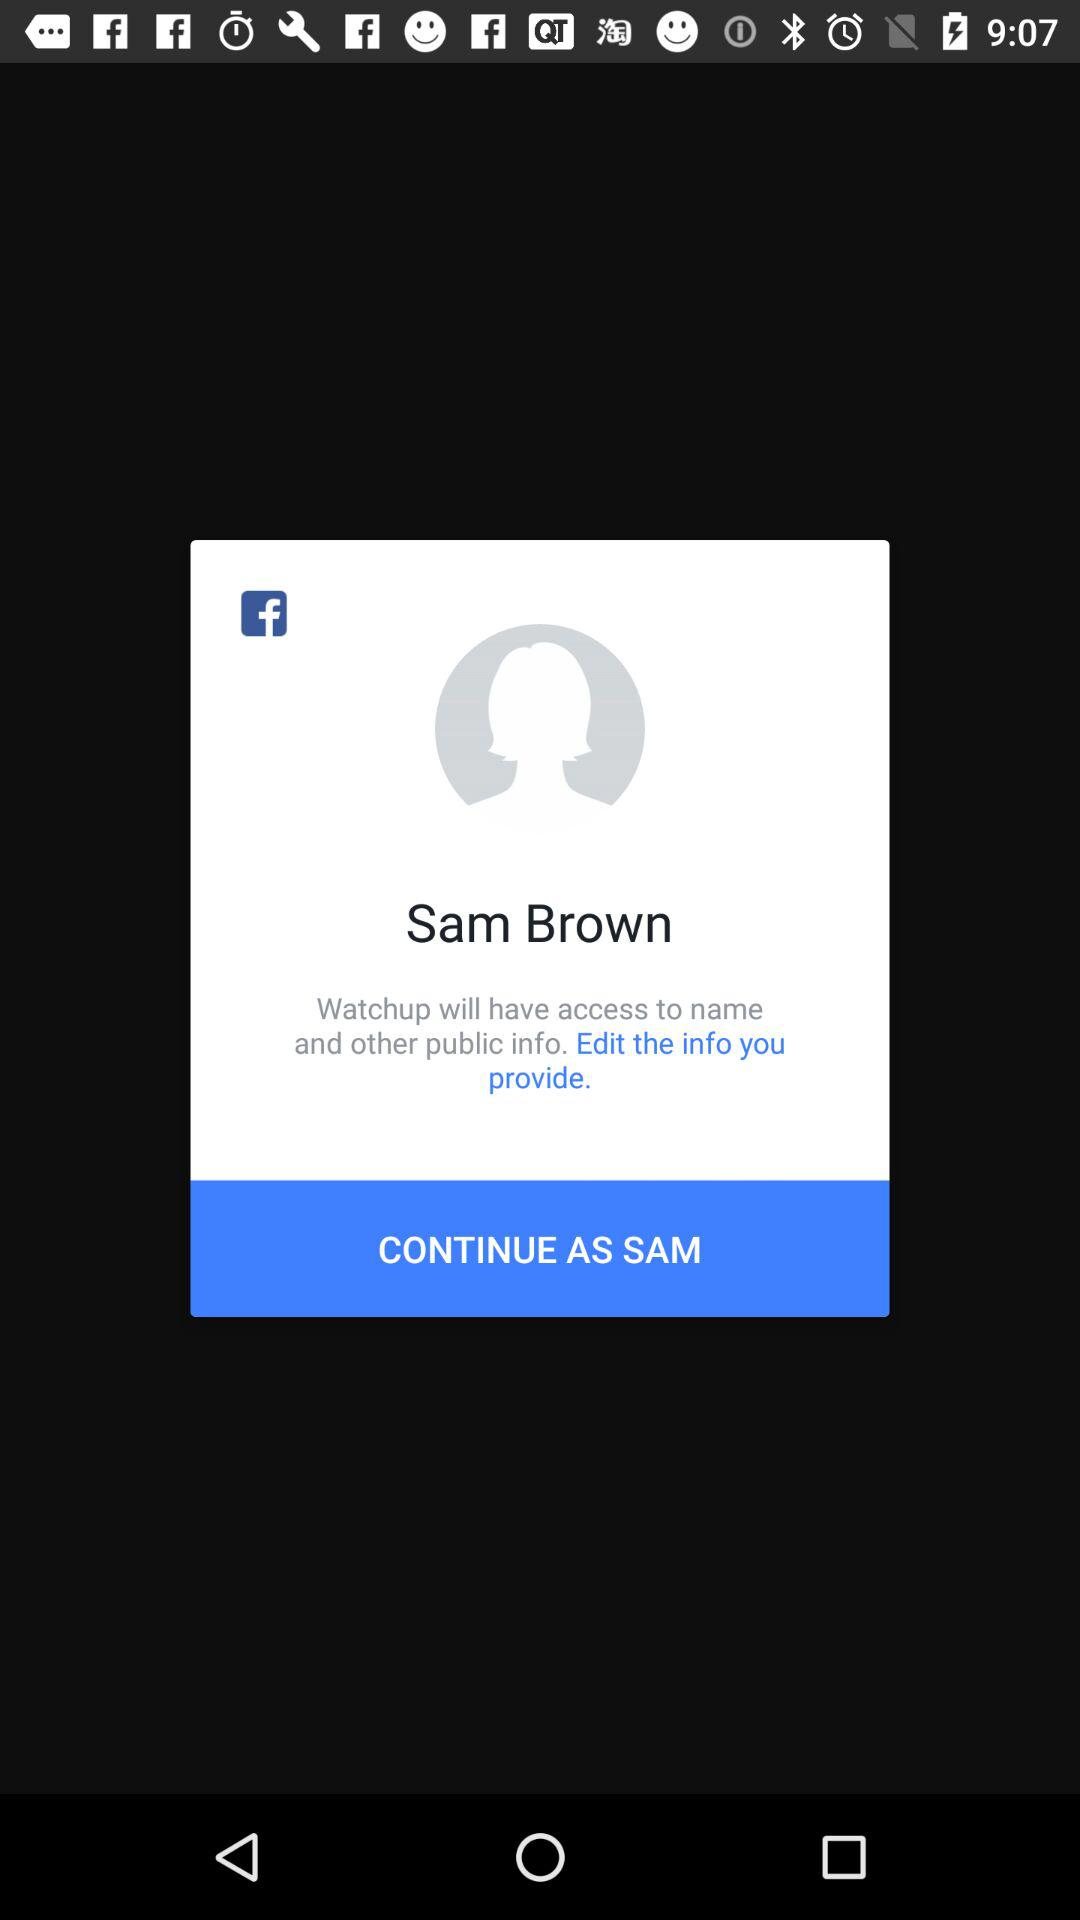Is the provided information edited?
When the provided information is insufficient, respond with <no answer>. <no answer> 